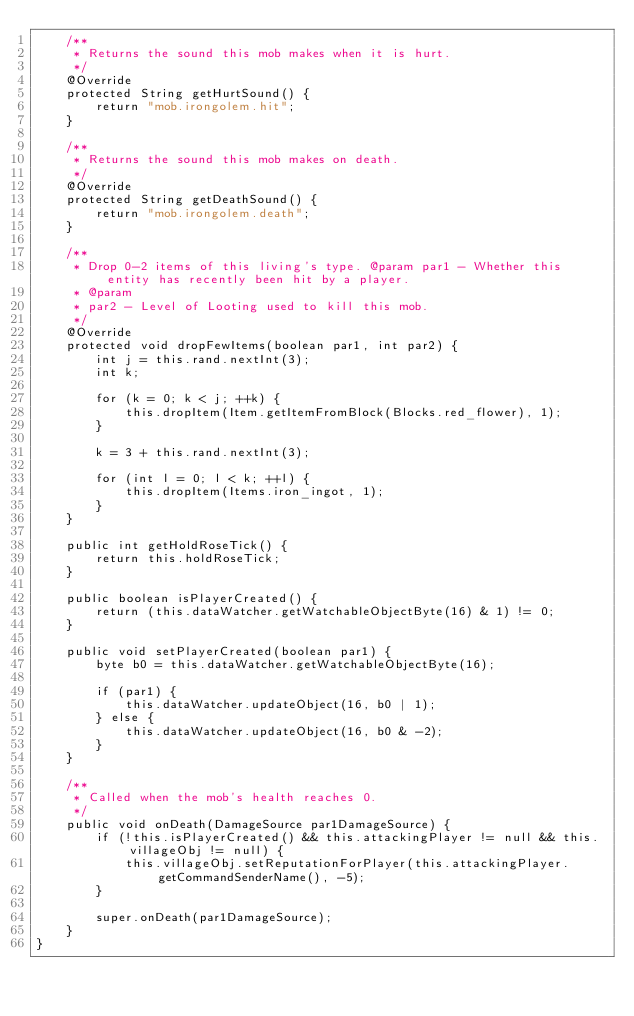Convert code to text. <code><loc_0><loc_0><loc_500><loc_500><_Java_>	/**
	 * Returns the sound this mob makes when it is hurt.
	 */
	@Override
	protected String getHurtSound() {
		return "mob.irongolem.hit";
	}

	/**
	 * Returns the sound this mob makes on death.
	 */
	@Override
	protected String getDeathSound() {
		return "mob.irongolem.death";
	}

	/**
	 * Drop 0-2 items of this living's type. @param par1 - Whether this entity has recently been hit by a player.
	 * @param
	 * par2 - Level of Looting used to kill this mob.
	 */
	@Override
	protected void dropFewItems(boolean par1, int par2) {
		int j = this.rand.nextInt(3);
		int k;

		for (k = 0; k < j; ++k) {
			this.dropItem(Item.getItemFromBlock(Blocks.red_flower), 1);
		}

		k = 3 + this.rand.nextInt(3);

		for (int l = 0; l < k; ++l) {
			this.dropItem(Items.iron_ingot, 1);
		}
	}

	public int getHoldRoseTick() {
		return this.holdRoseTick;
	}

	public boolean isPlayerCreated() {
		return (this.dataWatcher.getWatchableObjectByte(16) & 1) != 0;
	}

	public void setPlayerCreated(boolean par1) {
		byte b0 = this.dataWatcher.getWatchableObjectByte(16);

		if (par1) {
			this.dataWatcher.updateObject(16, b0 | 1);
		} else {
			this.dataWatcher.updateObject(16, b0 & -2);
		}
	}

	/**
	 * Called when the mob's health reaches 0.
	 */
	public void onDeath(DamageSource par1DamageSource) {
		if (!this.isPlayerCreated() && this.attackingPlayer != null && this.villageObj != null) {
			this.villageObj.setReputationForPlayer(this.attackingPlayer.getCommandSenderName(), -5);
		}

		super.onDeath(par1DamageSource);
	}
}</code> 